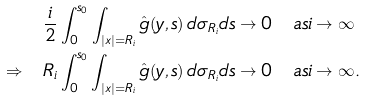<formula> <loc_0><loc_0><loc_500><loc_500>& \frac { i } { 2 } \int _ { 0 } ^ { s _ { 0 } } \int _ { | x | = R _ { i } } \hat { g } ( y , s ) \, d \sigma _ { R _ { i } } d s \to 0 \quad a s i \to \infty \\ \Rightarrow \quad & R _ { i } \int _ { 0 } ^ { s _ { 0 } } \int _ { | x | = R _ { i } } \hat { g } ( y , s ) \, d \sigma _ { R _ { i } } d s \to 0 \quad a s i \to \infty .</formula> 